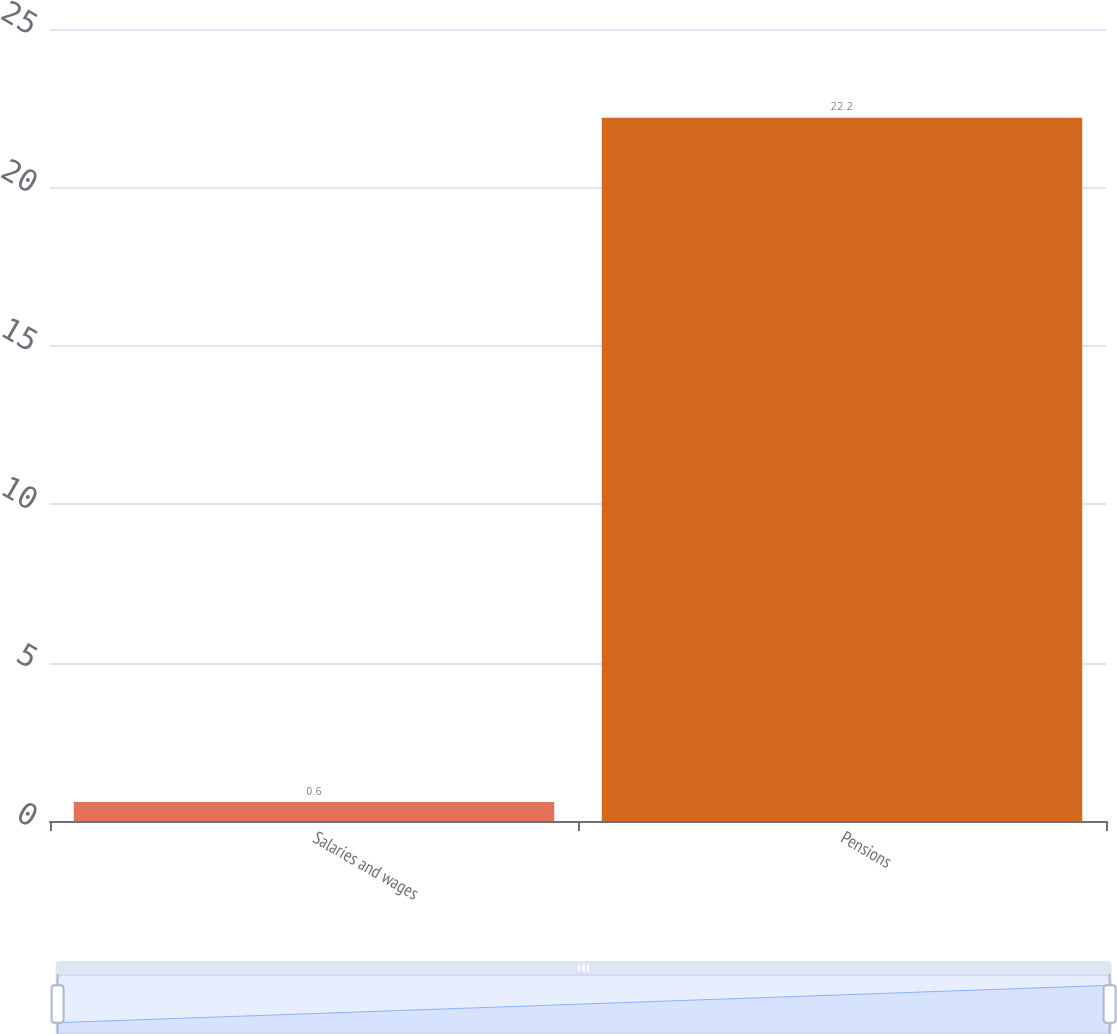Convert chart. <chart><loc_0><loc_0><loc_500><loc_500><bar_chart><fcel>Salaries and wages<fcel>Pensions<nl><fcel>0.6<fcel>22.2<nl></chart> 